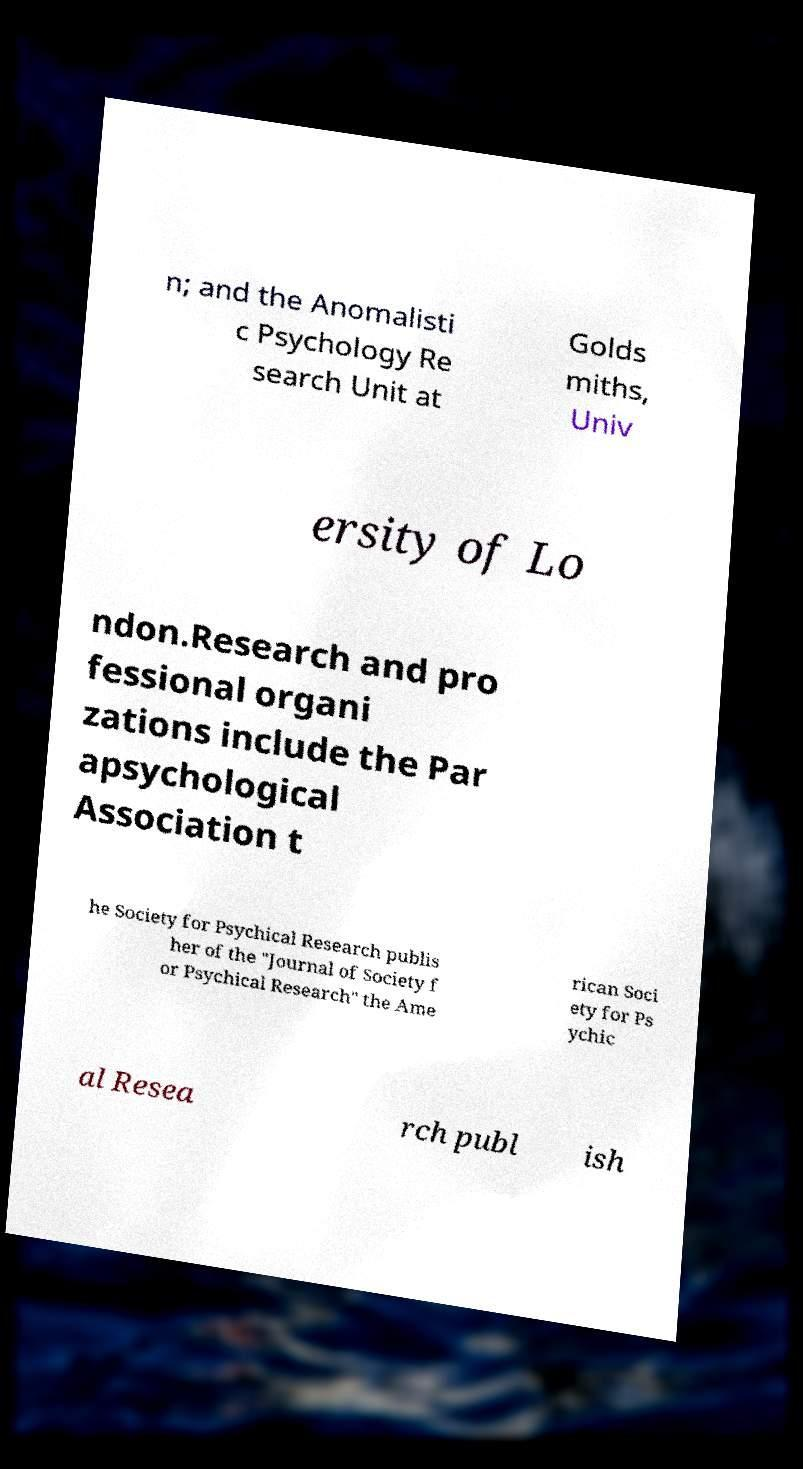For documentation purposes, I need the text within this image transcribed. Could you provide that? n; and the Anomalisti c Psychology Re search Unit at Golds miths, Univ ersity of Lo ndon.Research and pro fessional organi zations include the Par apsychological Association t he Society for Psychical Research publis her of the "Journal of Society f or Psychical Research" the Ame rican Soci ety for Ps ychic al Resea rch publ ish 